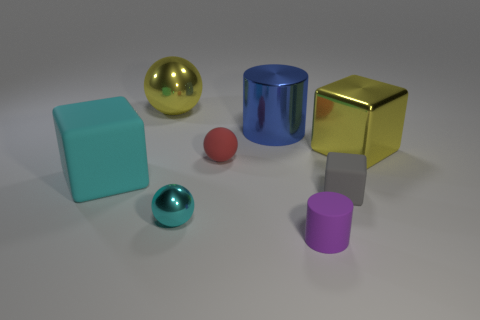Add 1 red objects. How many objects exist? 9 Subtract all balls. How many objects are left? 5 Subtract all small cylinders. Subtract all gray matte cubes. How many objects are left? 6 Add 1 small red spheres. How many small red spheres are left? 2 Add 3 cyan blocks. How many cyan blocks exist? 4 Subtract 1 cyan cubes. How many objects are left? 7 